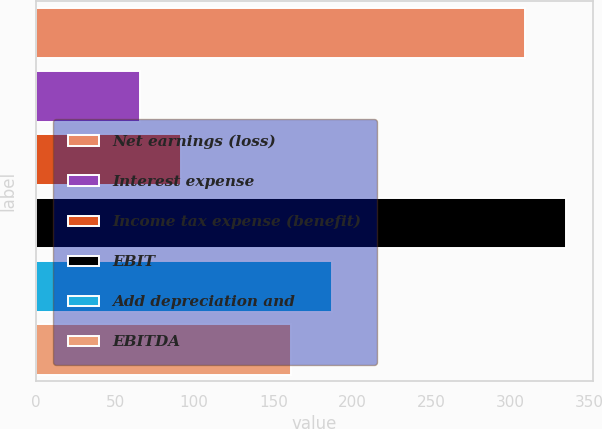Convert chart. <chart><loc_0><loc_0><loc_500><loc_500><bar_chart><fcel>Net earnings (loss)<fcel>Interest expense<fcel>Income tax expense (benefit)<fcel>EBIT<fcel>Add depreciation and<fcel>EBITDA<nl><fcel>309.1<fcel>65.9<fcel>91.91<fcel>335.11<fcel>187.01<fcel>161<nl></chart> 